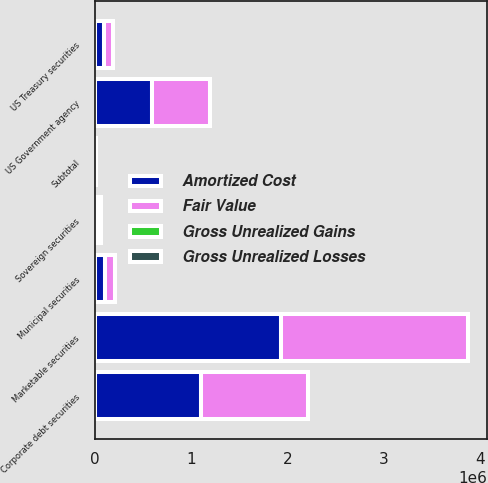Convert chart to OTSL. <chart><loc_0><loc_0><loc_500><loc_500><stacked_bar_chart><ecel><fcel>US Treasury securities<fcel>US Government agency<fcel>Municipal securities<fcel>Corporate debt securities<fcel>Sovereign securities<fcel>Subtotal<fcel>Marketable securities<nl><fcel>Fair Value<fcel>93940<fcel>598471<fcel>103686<fcel>1.10344e+06<fcel>33799<fcel>4002<fcel>1.93442e+06<nl><fcel>Gross Unrealized Gains<fcel>53<fcel>569<fcel>71<fcel>2353<fcel>25<fcel>3071<fcel>3071<nl><fcel>Gross Unrealized Losses<fcel>206<fcel>1009<fcel>302<fcel>2466<fcel>19<fcel>4002<fcel>4002<nl><fcel>Amortized Cost<fcel>93787<fcel>598031<fcel>103455<fcel>1.10332e+06<fcel>33805<fcel>4002<fcel>1.93349e+06<nl></chart> 